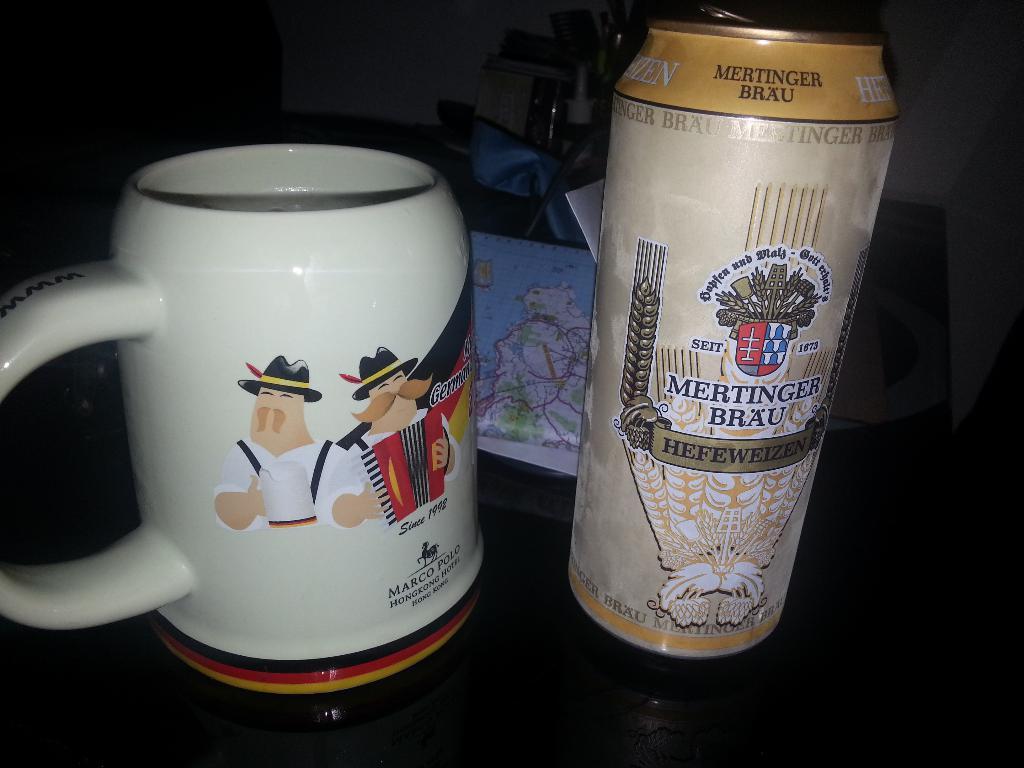What is the right mug name?
Keep it short and to the point. Mertinger brau. 